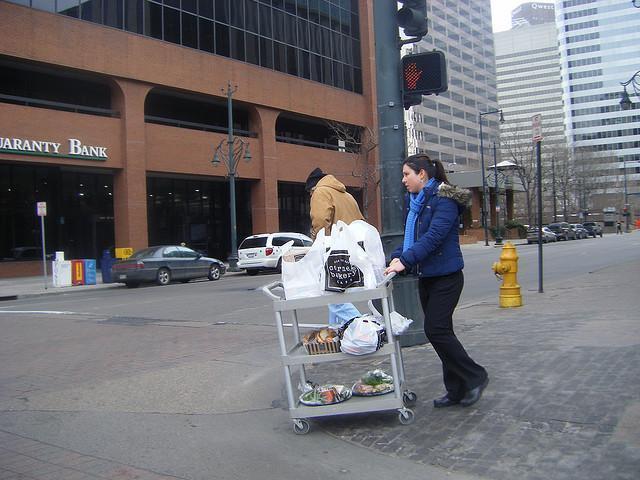How many people are in the photo?
Give a very brief answer. 2. How many cars are in the picture?
Give a very brief answer. 2. 